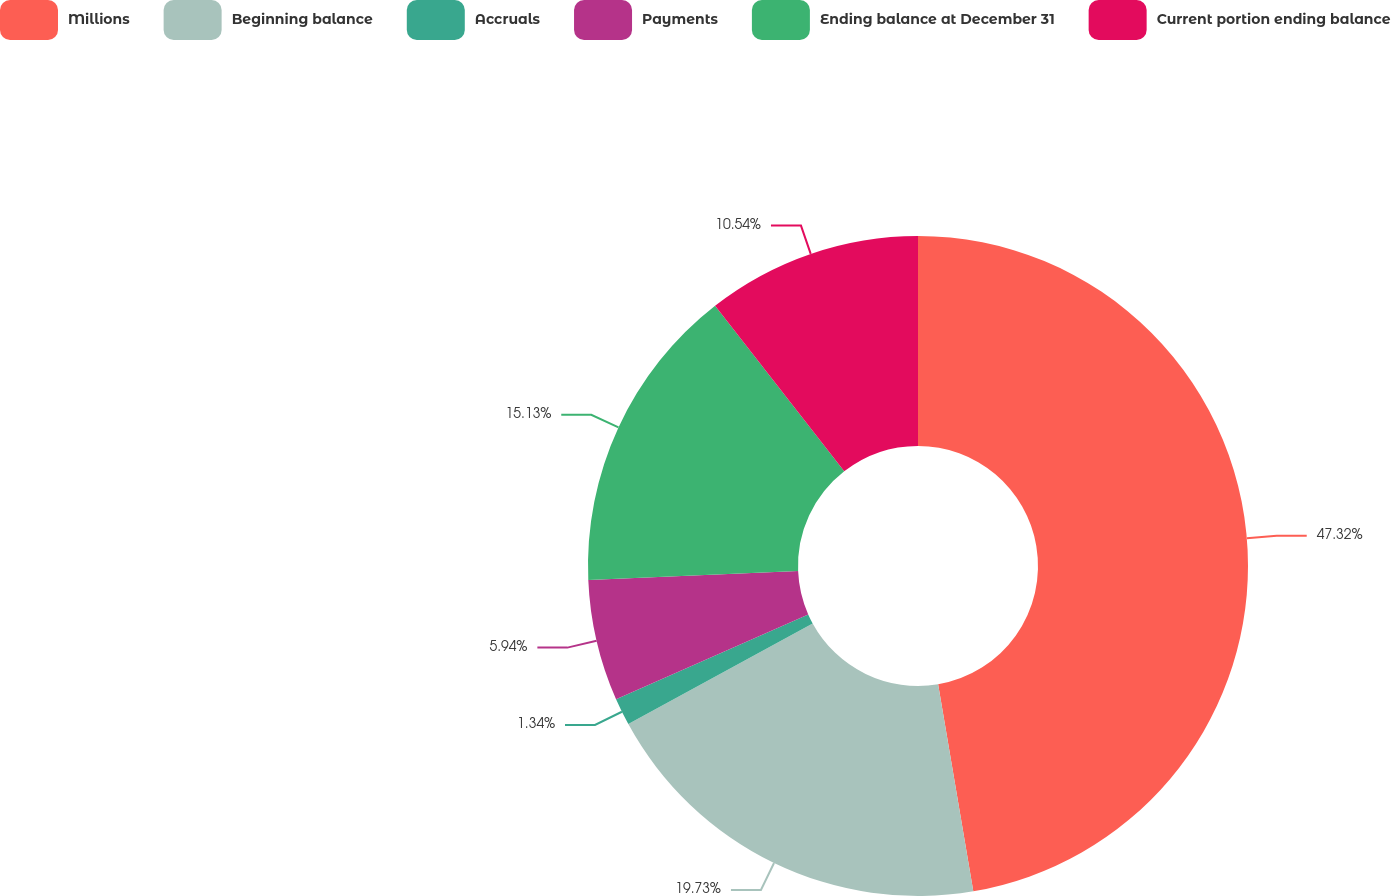Convert chart to OTSL. <chart><loc_0><loc_0><loc_500><loc_500><pie_chart><fcel>Millions<fcel>Beginning balance<fcel>Accruals<fcel>Payments<fcel>Ending balance at December 31<fcel>Current portion ending balance<nl><fcel>47.32%<fcel>19.73%<fcel>1.34%<fcel>5.94%<fcel>15.13%<fcel>10.54%<nl></chart> 